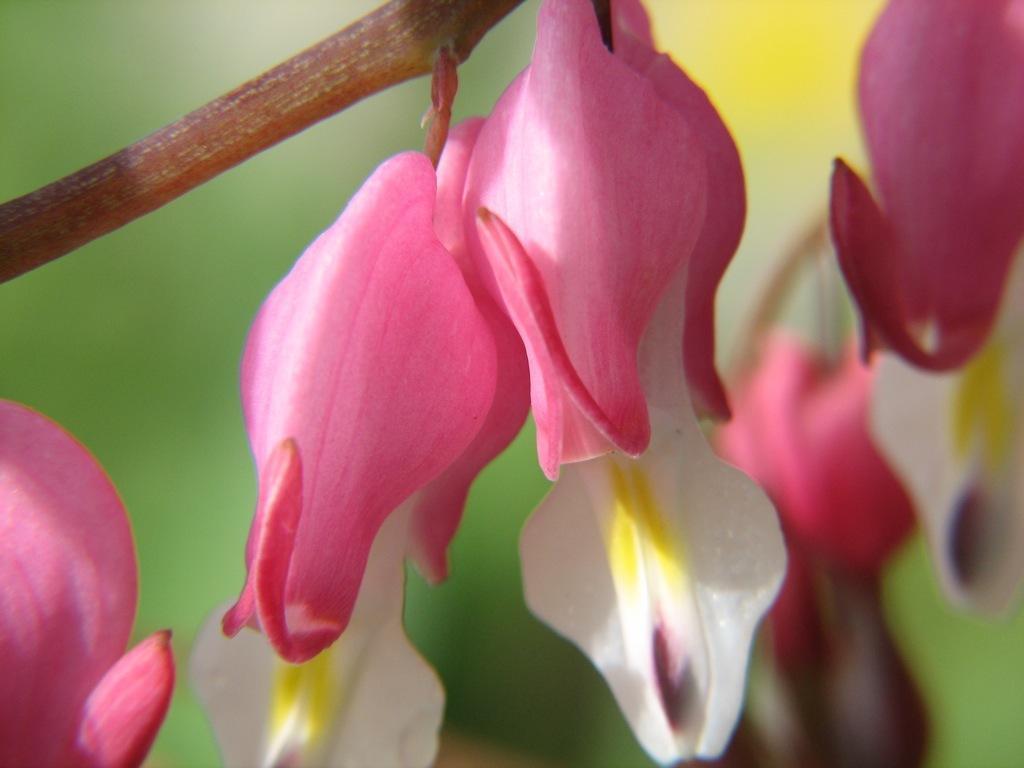Describe this image in one or two sentences. In this image we can see group of flowers on the stem of a plant. 